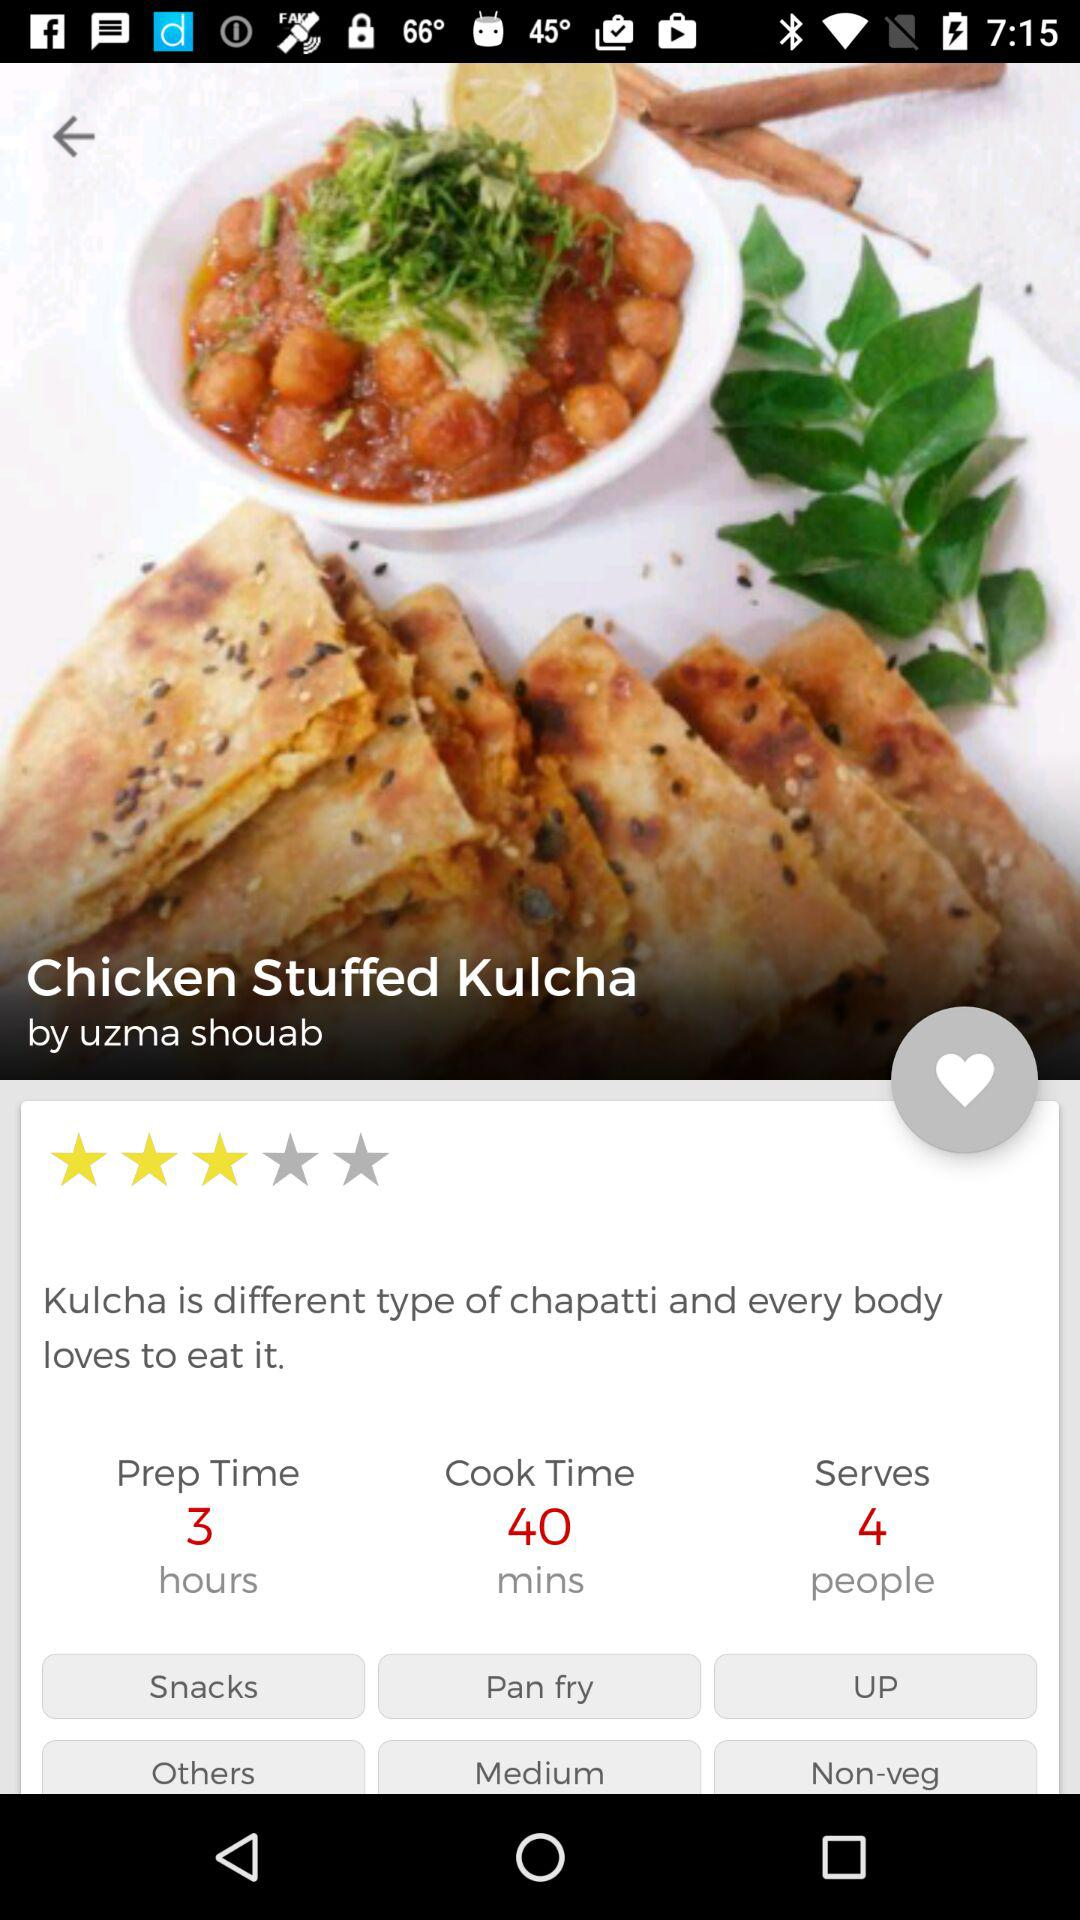Can you tell me what the dish is called? The dish is called Chicken Stuffed Kulcha, as stated in the image. What are the key ingredients likely used in this dish? Key ingredients for Chicken Stuffed Kulcha likely include chicken, flour for the kulcha bread, and various spices and herbs for flavoring. 